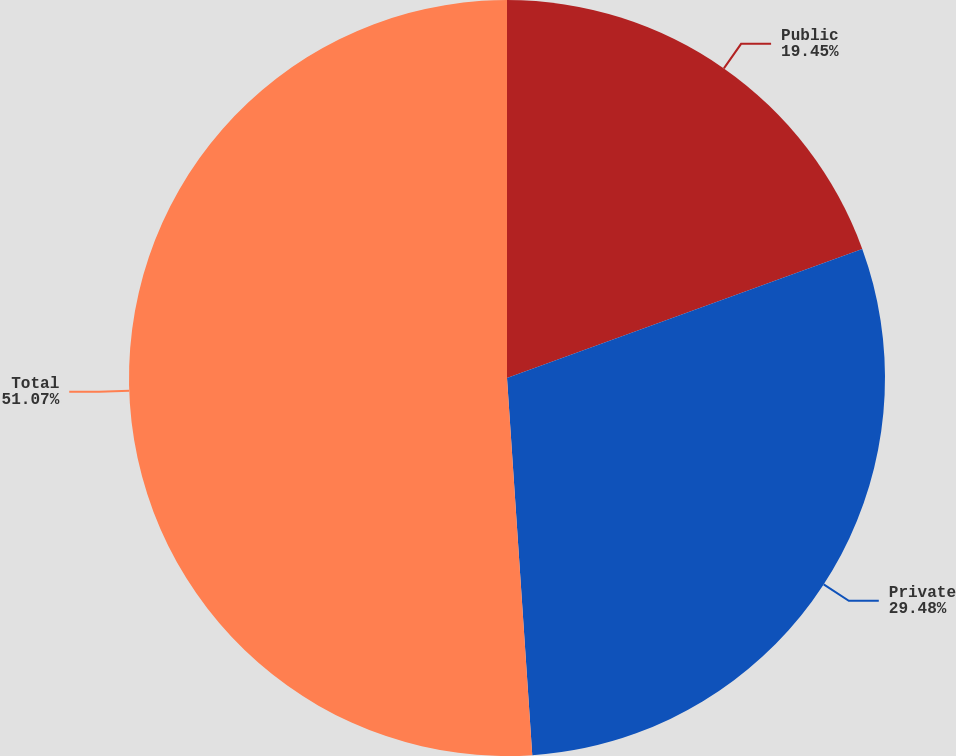<chart> <loc_0><loc_0><loc_500><loc_500><pie_chart><fcel>Public<fcel>Private<fcel>Total<nl><fcel>19.45%<fcel>29.48%<fcel>51.06%<nl></chart> 